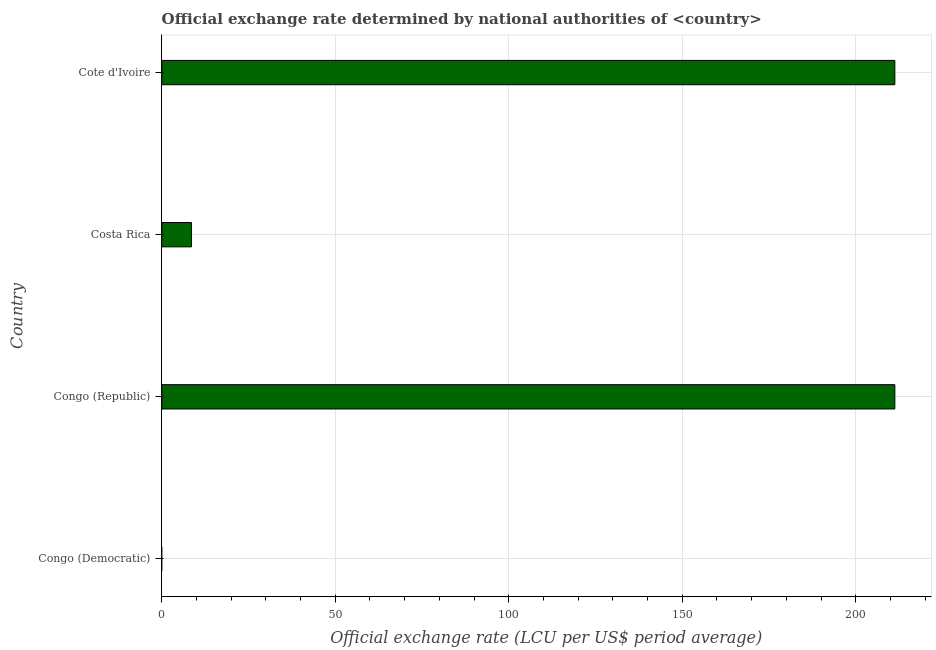What is the title of the graph?
Offer a terse response. Official exchange rate determined by national authorities of <country>. What is the label or title of the X-axis?
Offer a very short reply. Official exchange rate (LCU per US$ period average). What is the label or title of the Y-axis?
Give a very brief answer. Country. What is the official exchange rate in Cote d'Ivoire?
Provide a succinct answer. 211.28. Across all countries, what is the maximum official exchange rate?
Ensure brevity in your answer.  211.28. Across all countries, what is the minimum official exchange rate?
Give a very brief answer. 9.33083333333333e-12. In which country was the official exchange rate maximum?
Give a very brief answer. Congo (Republic). In which country was the official exchange rate minimum?
Offer a terse response. Congo (Democratic). What is the sum of the official exchange rate?
Offer a terse response. 431.13. What is the difference between the official exchange rate in Congo (Democratic) and Costa Rica?
Your response must be concise. -8.57. What is the average official exchange rate per country?
Keep it short and to the point. 107.78. What is the median official exchange rate?
Offer a very short reply. 109.92. What is the ratio of the official exchange rate in Costa Rica to that in Cote d'Ivoire?
Ensure brevity in your answer.  0.04. What is the difference between the highest and the second highest official exchange rate?
Provide a short and direct response. 0. What is the difference between the highest and the lowest official exchange rate?
Offer a terse response. 211.28. In how many countries, is the official exchange rate greater than the average official exchange rate taken over all countries?
Provide a succinct answer. 2. Are all the bars in the graph horizontal?
Keep it short and to the point. Yes. What is the difference between two consecutive major ticks on the X-axis?
Offer a terse response. 50. What is the Official exchange rate (LCU per US$ period average) in Congo (Democratic)?
Provide a short and direct response. 9.33083333333333e-12. What is the Official exchange rate (LCU per US$ period average) of Congo (Republic)?
Give a very brief answer. 211.28. What is the Official exchange rate (LCU per US$ period average) of Costa Rica?
Provide a short and direct response. 8.57. What is the Official exchange rate (LCU per US$ period average) in Cote d'Ivoire?
Your answer should be very brief. 211.28. What is the difference between the Official exchange rate (LCU per US$ period average) in Congo (Democratic) and Congo (Republic)?
Ensure brevity in your answer.  -211.28. What is the difference between the Official exchange rate (LCU per US$ period average) in Congo (Democratic) and Costa Rica?
Your response must be concise. -8.57. What is the difference between the Official exchange rate (LCU per US$ period average) in Congo (Democratic) and Cote d'Ivoire?
Keep it short and to the point. -211.28. What is the difference between the Official exchange rate (LCU per US$ period average) in Congo (Republic) and Costa Rica?
Provide a succinct answer. 202.71. What is the difference between the Official exchange rate (LCU per US$ period average) in Costa Rica and Cote d'Ivoire?
Your answer should be compact. -202.71. What is the ratio of the Official exchange rate (LCU per US$ period average) in Congo (Democratic) to that in Costa Rica?
Keep it short and to the point. 0. What is the ratio of the Official exchange rate (LCU per US$ period average) in Congo (Democratic) to that in Cote d'Ivoire?
Make the answer very short. 0. What is the ratio of the Official exchange rate (LCU per US$ period average) in Congo (Republic) to that in Costa Rica?
Ensure brevity in your answer.  24.65. What is the ratio of the Official exchange rate (LCU per US$ period average) in Costa Rica to that in Cote d'Ivoire?
Offer a very short reply. 0.04. 